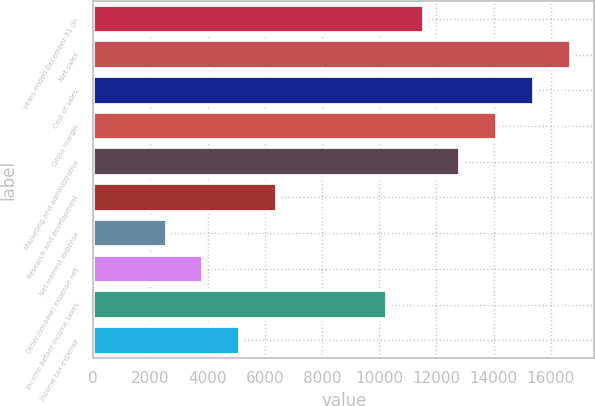Convert chart. <chart><loc_0><loc_0><loc_500><loc_500><bar_chart><fcel>years ended December 31 (in<fcel>Net sales<fcel>Cost of sales<fcel>Gross margin<fcel>Marketing and administrative<fcel>Research and development<fcel>Net interest expense<fcel>Other (income) expense net<fcel>Income before income taxes<fcel>Income tax expense<nl><fcel>11558.9<fcel>16695.2<fcel>15411.1<fcel>14127<fcel>12843<fcel>6422.69<fcel>2570.51<fcel>3854.57<fcel>10274.9<fcel>5138.63<nl></chart> 